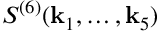Convert formula to latex. <formula><loc_0><loc_0><loc_500><loc_500>S ^ { ( 6 ) } ( k _ { 1 } , \dots , k _ { 5 } )</formula> 